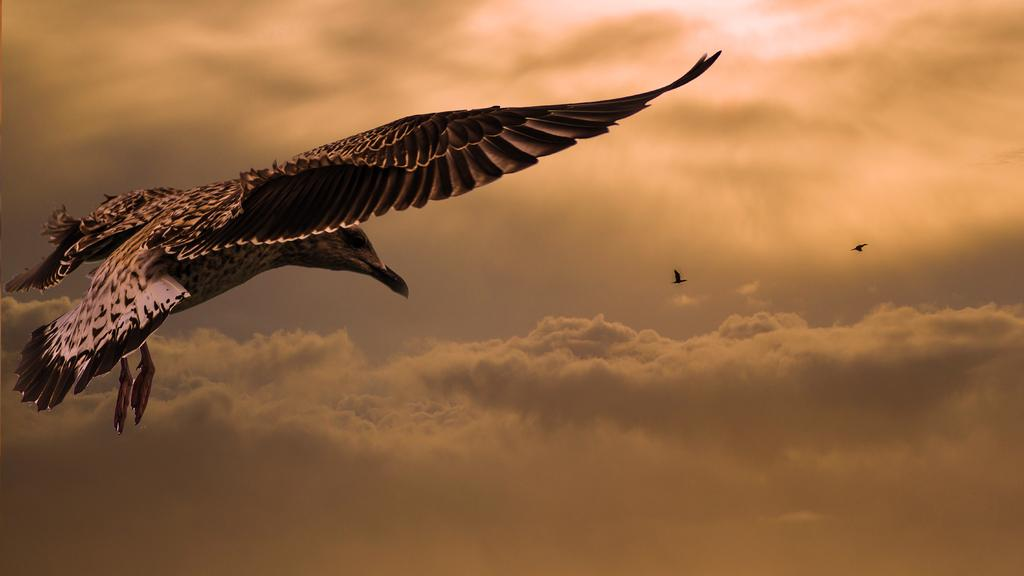What is happening in the image? There are birds flying in the image. What can be seen at the top of the image? The sky is visible at the top of the image. What is present in the sky? There are clouds in the sky. What route are the birds taking in the image? There is no specific route mentioned or visible for the birds in the image. 